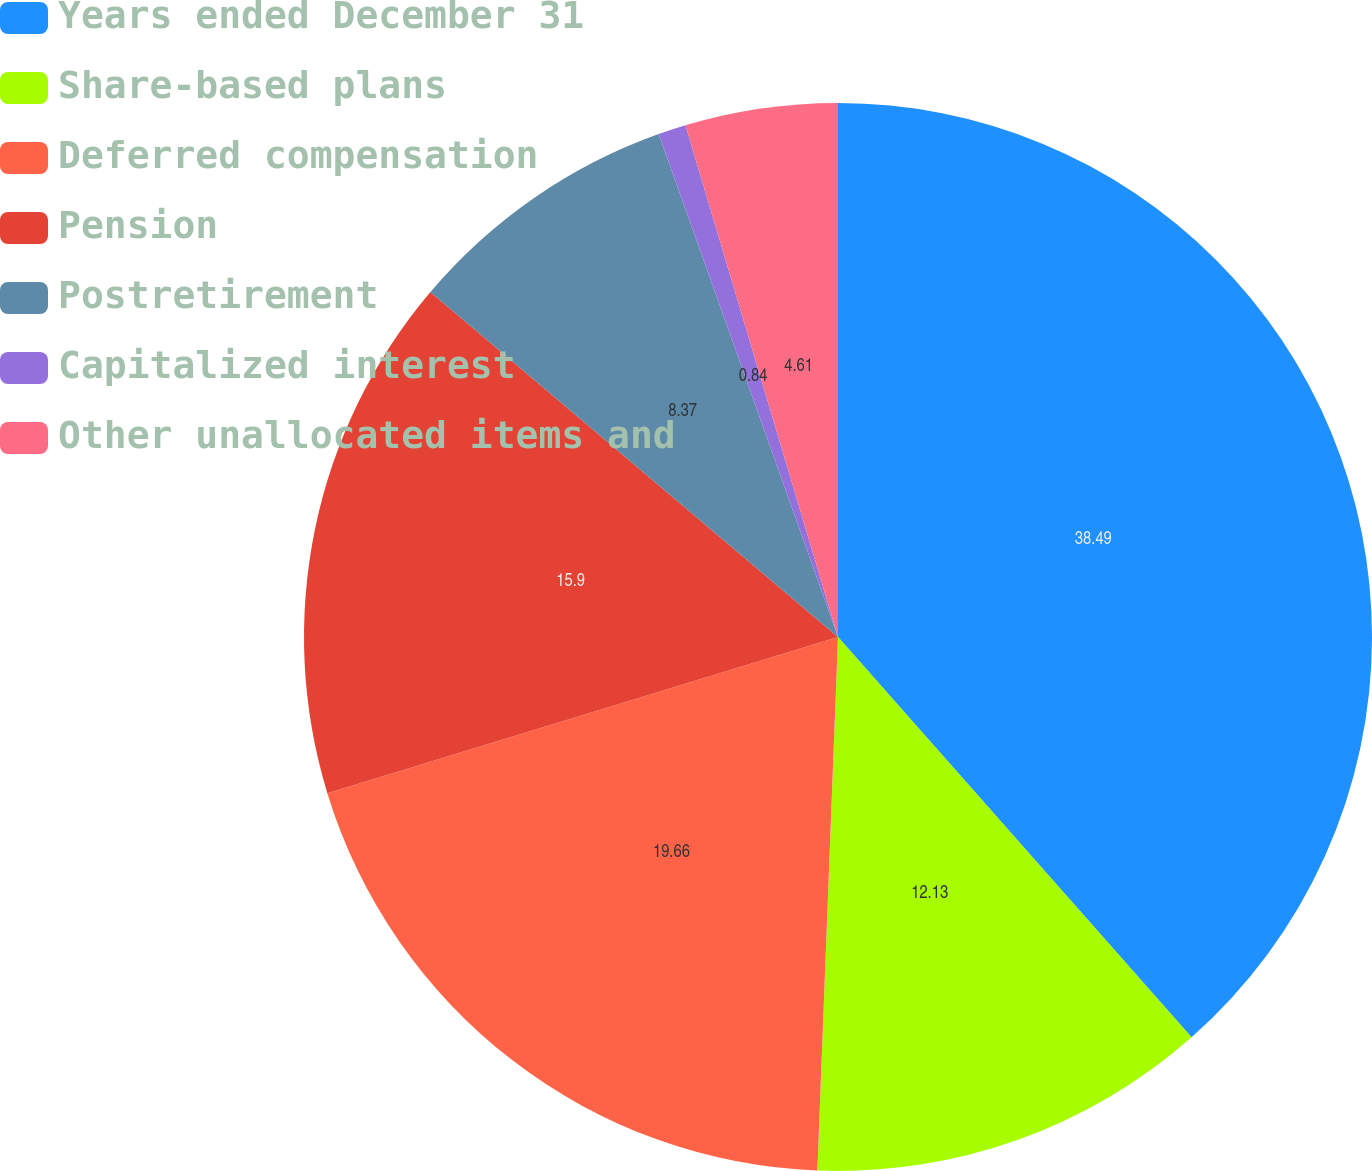Convert chart to OTSL. <chart><loc_0><loc_0><loc_500><loc_500><pie_chart><fcel>Years ended December 31<fcel>Share-based plans<fcel>Deferred compensation<fcel>Pension<fcel>Postretirement<fcel>Capitalized interest<fcel>Other unallocated items and<nl><fcel>38.48%<fcel>12.13%<fcel>19.66%<fcel>15.9%<fcel>8.37%<fcel>0.84%<fcel>4.61%<nl></chart> 